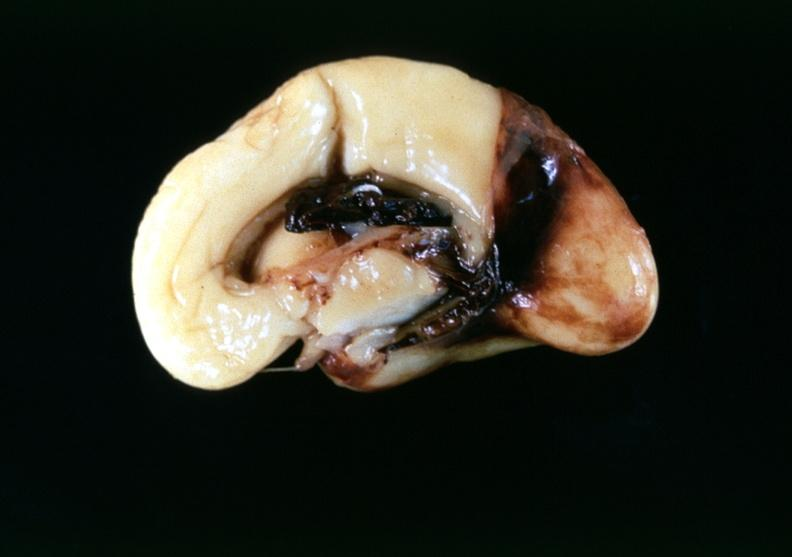what does this image show?
Answer the question using a single word or phrase. Brain 